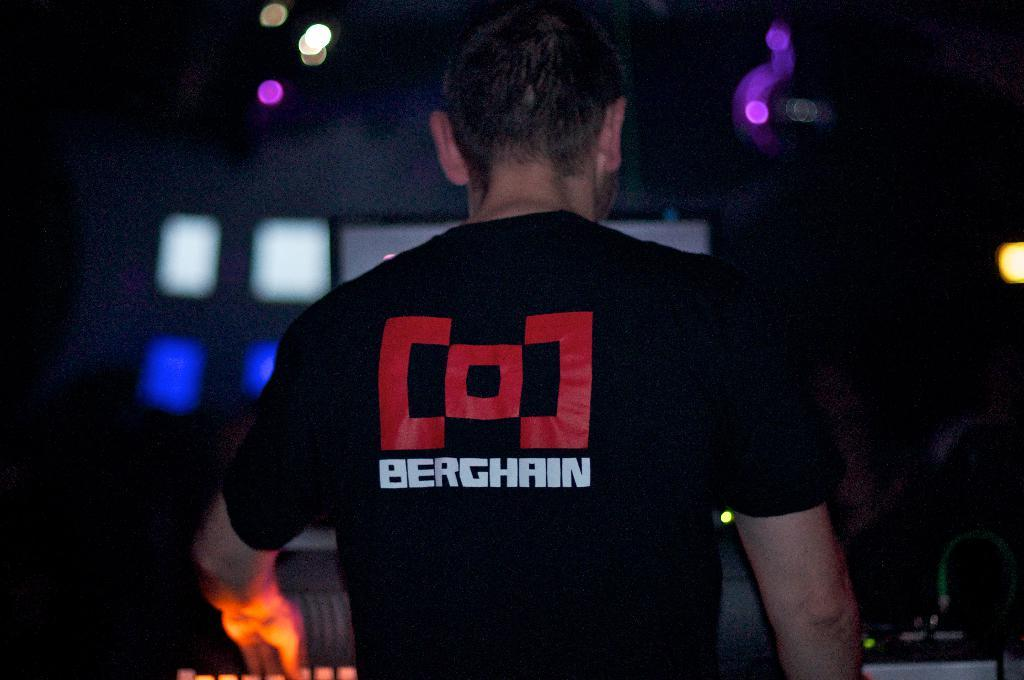Who is present in the image? There is a man in the image. What can be seen in the background of the image? There are lights visible in the background of the image. How would you describe the overall lighting in the image? The image appears to be dark. What holiday is the queen celebrating in the image? There is no queen or holiday present in the image; it features a man and lights in the background. 